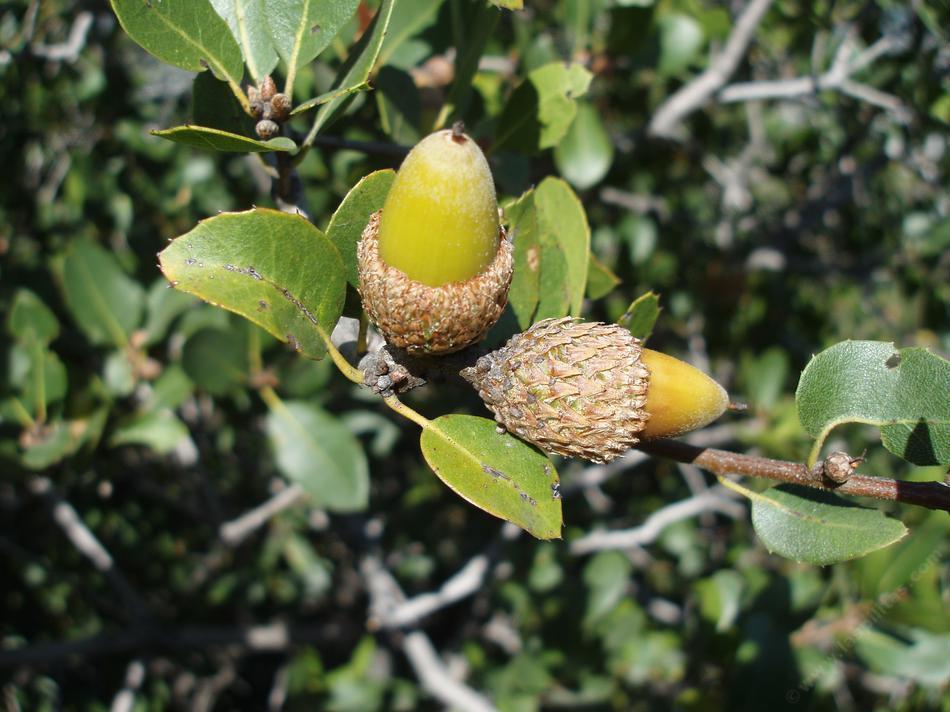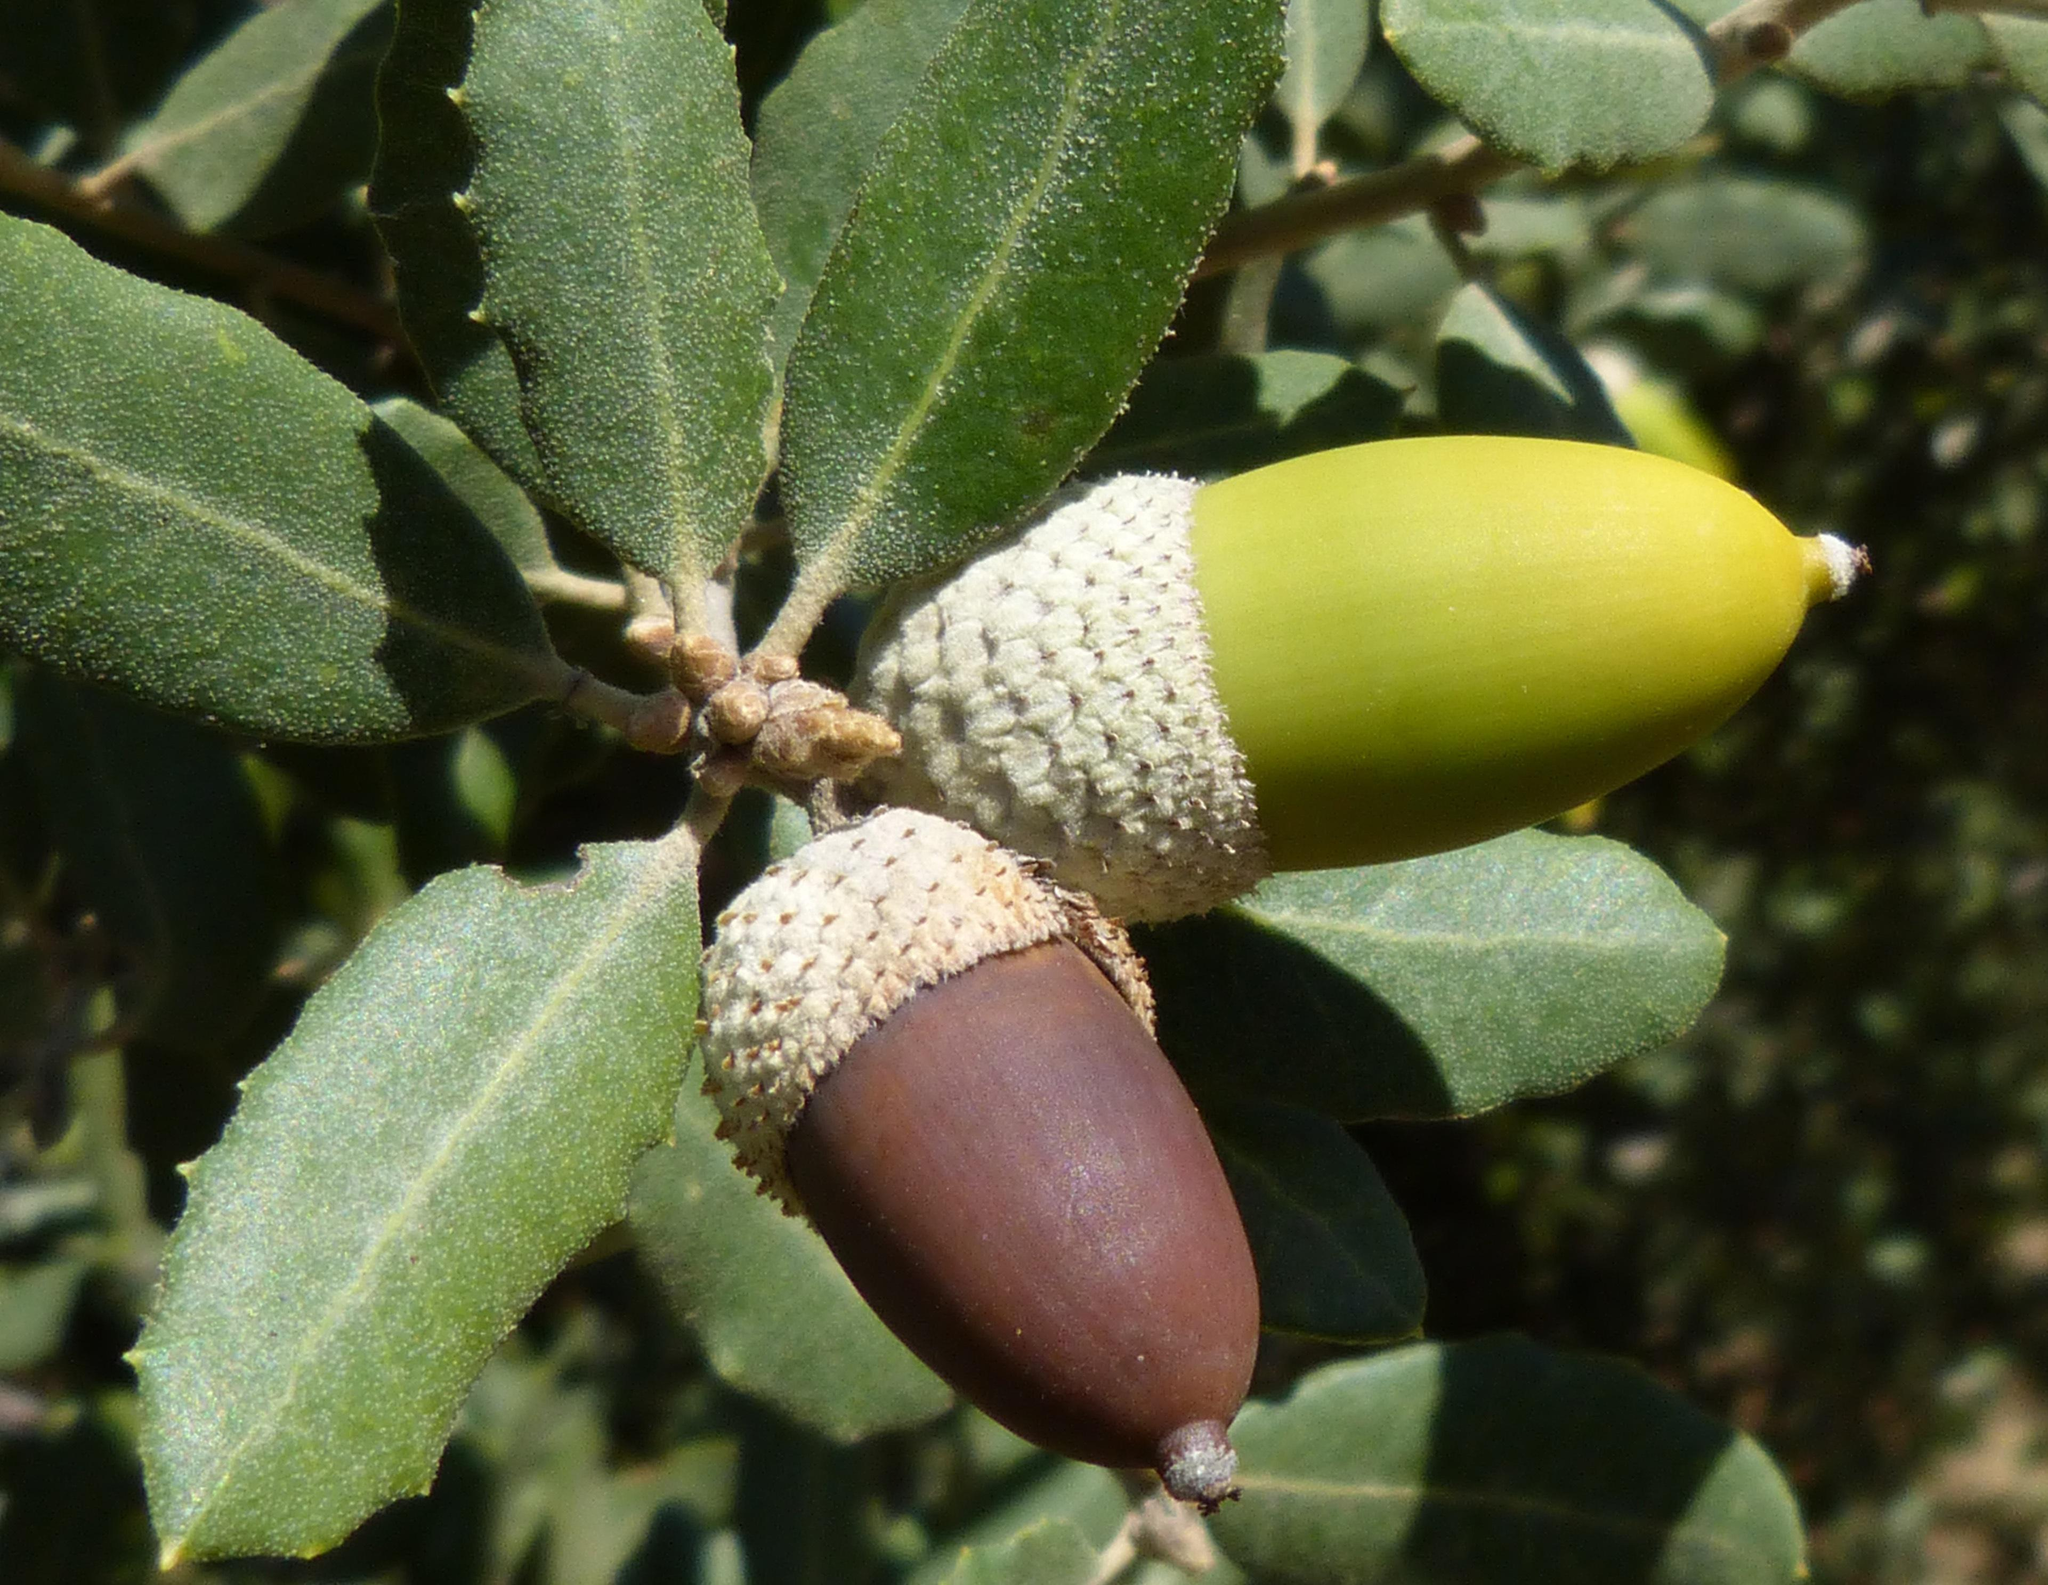The first image is the image on the left, the second image is the image on the right. Evaluate the accuracy of this statement regarding the images: "Acorns are growing on trees in each of the images.". Is it true? Answer yes or no. Yes. The first image is the image on the left, the second image is the image on the right. Analyze the images presented: Is the assertion "Each image shows acorns growing on a tree with green leaves, and in total, most acorns are green and most acorns are slender." valid? Answer yes or no. Yes. 